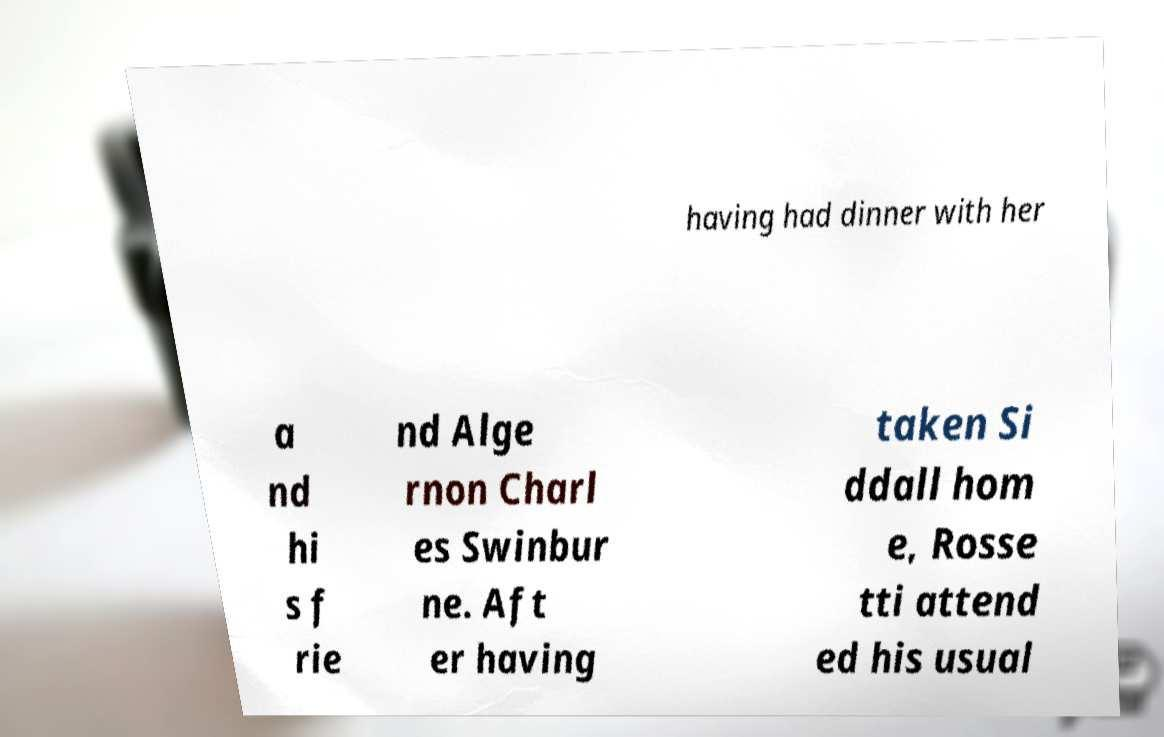I need the written content from this picture converted into text. Can you do that? having had dinner with her a nd hi s f rie nd Alge rnon Charl es Swinbur ne. Aft er having taken Si ddall hom e, Rosse tti attend ed his usual 